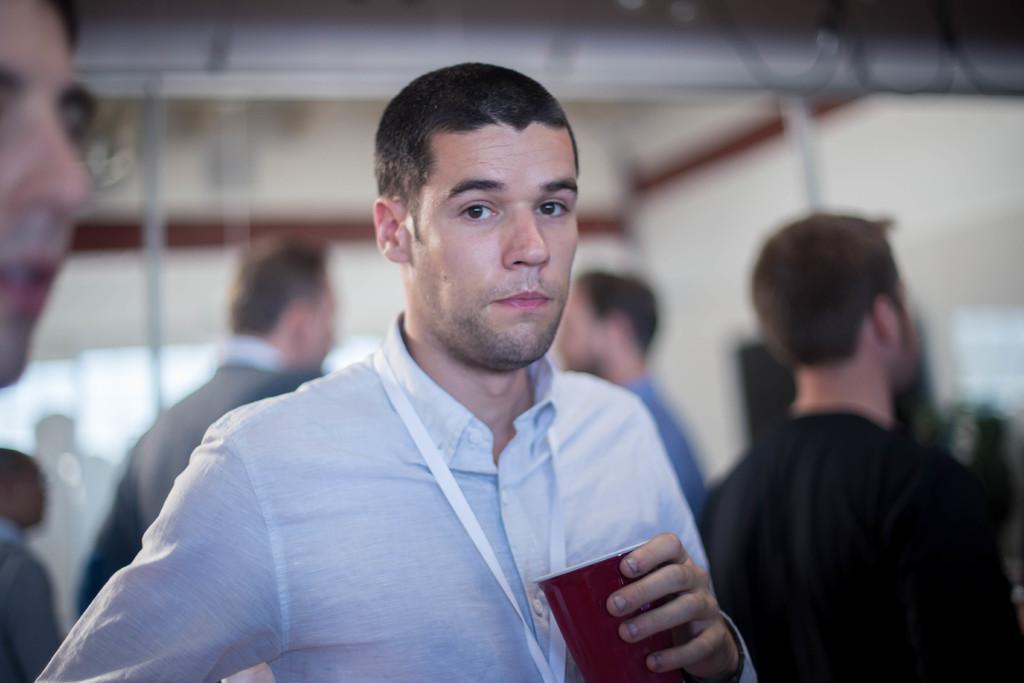In one or two sentences, can you explain what this image depicts? There is a man holding a glass in the foreground area of the image, there are people in the background. 